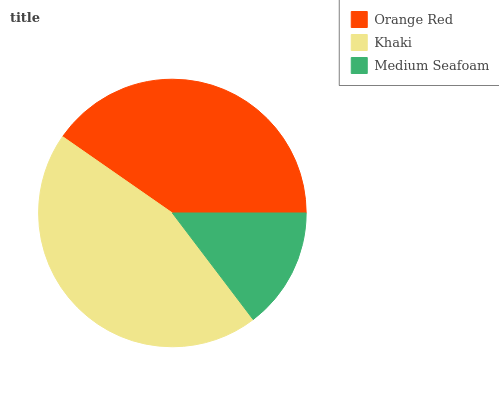Is Medium Seafoam the minimum?
Answer yes or no. Yes. Is Khaki the maximum?
Answer yes or no. Yes. Is Khaki the minimum?
Answer yes or no. No. Is Medium Seafoam the maximum?
Answer yes or no. No. Is Khaki greater than Medium Seafoam?
Answer yes or no. Yes. Is Medium Seafoam less than Khaki?
Answer yes or no. Yes. Is Medium Seafoam greater than Khaki?
Answer yes or no. No. Is Khaki less than Medium Seafoam?
Answer yes or no. No. Is Orange Red the high median?
Answer yes or no. Yes. Is Orange Red the low median?
Answer yes or no. Yes. Is Medium Seafoam the high median?
Answer yes or no. No. Is Khaki the low median?
Answer yes or no. No. 